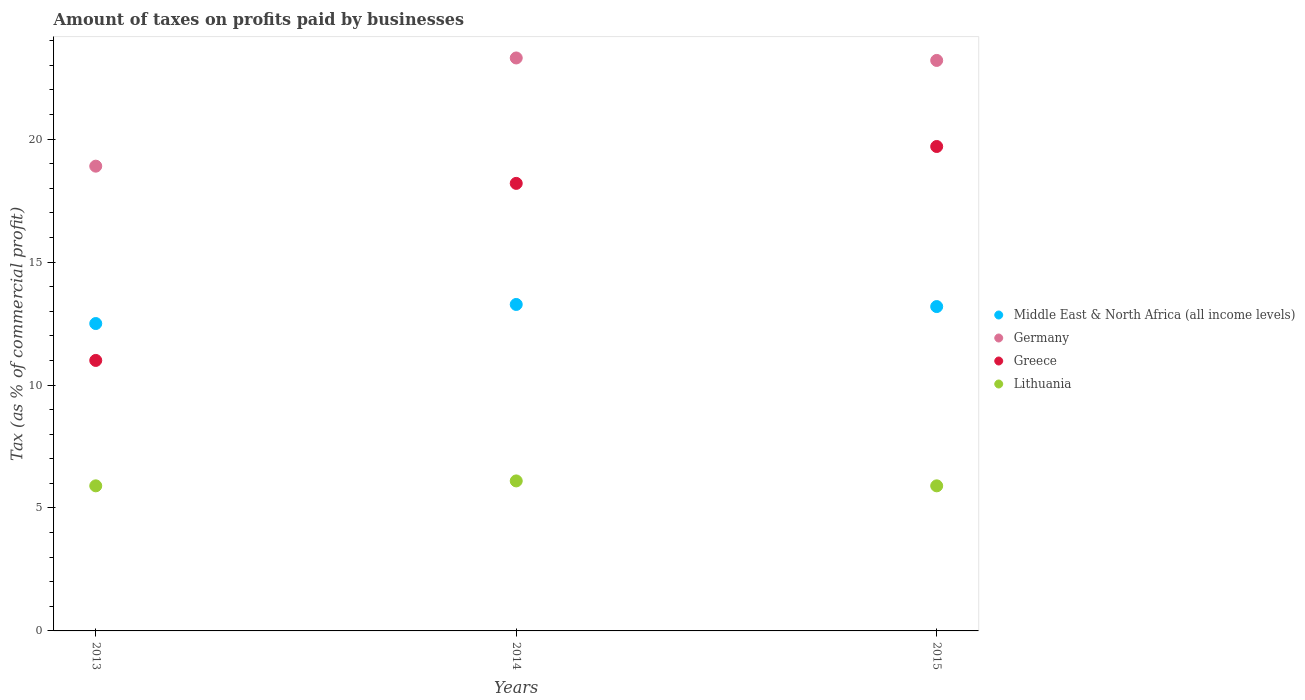How many different coloured dotlines are there?
Provide a short and direct response. 4. What is the percentage of taxes paid by businesses in Lithuania in 2015?
Your response must be concise. 5.9. Across all years, what is the minimum percentage of taxes paid by businesses in Middle East & North Africa (all income levels)?
Provide a short and direct response. 12.5. In which year was the percentage of taxes paid by businesses in Middle East & North Africa (all income levels) maximum?
Offer a very short reply. 2014. What is the total percentage of taxes paid by businesses in Middle East & North Africa (all income levels) in the graph?
Your response must be concise. 38.97. What is the difference between the percentage of taxes paid by businesses in Lithuania in 2014 and that in 2015?
Provide a short and direct response. 0.2. What is the average percentage of taxes paid by businesses in Middle East & North Africa (all income levels) per year?
Give a very brief answer. 12.99. In the year 2013, what is the difference between the percentage of taxes paid by businesses in Lithuania and percentage of taxes paid by businesses in Greece?
Keep it short and to the point. -5.1. In how many years, is the percentage of taxes paid by businesses in Greece greater than 16 %?
Give a very brief answer. 2. What is the ratio of the percentage of taxes paid by businesses in Germany in 2014 to that in 2015?
Offer a very short reply. 1. Is the percentage of taxes paid by businesses in Lithuania in 2014 less than that in 2015?
Offer a terse response. No. What is the difference between the highest and the second highest percentage of taxes paid by businesses in Greece?
Give a very brief answer. 1.5. What is the difference between the highest and the lowest percentage of taxes paid by businesses in Lithuania?
Keep it short and to the point. 0.2. Is the sum of the percentage of taxes paid by businesses in Germany in 2013 and 2015 greater than the maximum percentage of taxes paid by businesses in Greece across all years?
Offer a very short reply. Yes. Is it the case that in every year, the sum of the percentage of taxes paid by businesses in Lithuania and percentage of taxes paid by businesses in Germany  is greater than the percentage of taxes paid by businesses in Middle East & North Africa (all income levels)?
Make the answer very short. Yes. Does the percentage of taxes paid by businesses in Germany monotonically increase over the years?
Ensure brevity in your answer.  No. Is the percentage of taxes paid by businesses in Germany strictly greater than the percentage of taxes paid by businesses in Lithuania over the years?
Your answer should be very brief. Yes. How many dotlines are there?
Provide a short and direct response. 4. How many years are there in the graph?
Provide a short and direct response. 3. What is the difference between two consecutive major ticks on the Y-axis?
Keep it short and to the point. 5. Does the graph contain any zero values?
Provide a succinct answer. No. How are the legend labels stacked?
Offer a terse response. Vertical. What is the title of the graph?
Provide a succinct answer. Amount of taxes on profits paid by businesses. Does "Iceland" appear as one of the legend labels in the graph?
Make the answer very short. No. What is the label or title of the Y-axis?
Give a very brief answer. Tax (as % of commercial profit). What is the Tax (as % of commercial profit) in Middle East & North Africa (all income levels) in 2013?
Your response must be concise. 12.5. What is the Tax (as % of commercial profit) of Lithuania in 2013?
Make the answer very short. 5.9. What is the Tax (as % of commercial profit) in Middle East & North Africa (all income levels) in 2014?
Your answer should be compact. 13.28. What is the Tax (as % of commercial profit) in Germany in 2014?
Your answer should be compact. 23.3. What is the Tax (as % of commercial profit) of Lithuania in 2014?
Your answer should be compact. 6.1. What is the Tax (as % of commercial profit) of Middle East & North Africa (all income levels) in 2015?
Offer a very short reply. 13.19. What is the Tax (as % of commercial profit) of Germany in 2015?
Give a very brief answer. 23.2. What is the Tax (as % of commercial profit) of Greece in 2015?
Ensure brevity in your answer.  19.7. Across all years, what is the maximum Tax (as % of commercial profit) in Middle East & North Africa (all income levels)?
Keep it short and to the point. 13.28. Across all years, what is the maximum Tax (as % of commercial profit) in Germany?
Make the answer very short. 23.3. Across all years, what is the minimum Tax (as % of commercial profit) in Middle East & North Africa (all income levels)?
Ensure brevity in your answer.  12.5. Across all years, what is the minimum Tax (as % of commercial profit) in Germany?
Ensure brevity in your answer.  18.9. What is the total Tax (as % of commercial profit) of Middle East & North Africa (all income levels) in the graph?
Offer a terse response. 38.97. What is the total Tax (as % of commercial profit) in Germany in the graph?
Ensure brevity in your answer.  65.4. What is the total Tax (as % of commercial profit) in Greece in the graph?
Provide a short and direct response. 48.9. What is the difference between the Tax (as % of commercial profit) in Middle East & North Africa (all income levels) in 2013 and that in 2014?
Keep it short and to the point. -0.78. What is the difference between the Tax (as % of commercial profit) of Germany in 2013 and that in 2014?
Offer a terse response. -4.4. What is the difference between the Tax (as % of commercial profit) of Middle East & North Africa (all income levels) in 2013 and that in 2015?
Your response must be concise. -0.69. What is the difference between the Tax (as % of commercial profit) of Greece in 2013 and that in 2015?
Provide a succinct answer. -8.7. What is the difference between the Tax (as % of commercial profit) in Middle East & North Africa (all income levels) in 2014 and that in 2015?
Provide a succinct answer. 0.09. What is the difference between the Tax (as % of commercial profit) in Lithuania in 2014 and that in 2015?
Your answer should be compact. 0.2. What is the difference between the Tax (as % of commercial profit) of Middle East & North Africa (all income levels) in 2013 and the Tax (as % of commercial profit) of Germany in 2014?
Your response must be concise. -10.8. What is the difference between the Tax (as % of commercial profit) of Germany in 2013 and the Tax (as % of commercial profit) of Greece in 2014?
Your answer should be compact. 0.7. What is the difference between the Tax (as % of commercial profit) in Germany in 2013 and the Tax (as % of commercial profit) in Lithuania in 2014?
Your answer should be compact. 12.8. What is the difference between the Tax (as % of commercial profit) of Greece in 2013 and the Tax (as % of commercial profit) of Lithuania in 2014?
Your answer should be compact. 4.9. What is the difference between the Tax (as % of commercial profit) of Middle East & North Africa (all income levels) in 2013 and the Tax (as % of commercial profit) of Greece in 2015?
Make the answer very short. -7.2. What is the difference between the Tax (as % of commercial profit) in Middle East & North Africa (all income levels) in 2014 and the Tax (as % of commercial profit) in Germany in 2015?
Offer a terse response. -9.92. What is the difference between the Tax (as % of commercial profit) in Middle East & North Africa (all income levels) in 2014 and the Tax (as % of commercial profit) in Greece in 2015?
Give a very brief answer. -6.42. What is the difference between the Tax (as % of commercial profit) in Middle East & North Africa (all income levels) in 2014 and the Tax (as % of commercial profit) in Lithuania in 2015?
Your answer should be very brief. 7.38. What is the difference between the Tax (as % of commercial profit) of Germany in 2014 and the Tax (as % of commercial profit) of Greece in 2015?
Provide a short and direct response. 3.6. What is the difference between the Tax (as % of commercial profit) of Germany in 2014 and the Tax (as % of commercial profit) of Lithuania in 2015?
Offer a very short reply. 17.4. What is the average Tax (as % of commercial profit) in Middle East & North Africa (all income levels) per year?
Ensure brevity in your answer.  12.99. What is the average Tax (as % of commercial profit) of Germany per year?
Provide a short and direct response. 21.8. What is the average Tax (as % of commercial profit) of Lithuania per year?
Ensure brevity in your answer.  5.97. In the year 2013, what is the difference between the Tax (as % of commercial profit) in Germany and Tax (as % of commercial profit) in Greece?
Keep it short and to the point. 7.9. In the year 2014, what is the difference between the Tax (as % of commercial profit) in Middle East & North Africa (all income levels) and Tax (as % of commercial profit) in Germany?
Provide a short and direct response. -10.02. In the year 2014, what is the difference between the Tax (as % of commercial profit) in Middle East & North Africa (all income levels) and Tax (as % of commercial profit) in Greece?
Make the answer very short. -4.92. In the year 2014, what is the difference between the Tax (as % of commercial profit) of Middle East & North Africa (all income levels) and Tax (as % of commercial profit) of Lithuania?
Keep it short and to the point. 7.18. In the year 2014, what is the difference between the Tax (as % of commercial profit) in Germany and Tax (as % of commercial profit) in Lithuania?
Your answer should be compact. 17.2. In the year 2015, what is the difference between the Tax (as % of commercial profit) of Middle East & North Africa (all income levels) and Tax (as % of commercial profit) of Germany?
Provide a short and direct response. -10.01. In the year 2015, what is the difference between the Tax (as % of commercial profit) of Middle East & North Africa (all income levels) and Tax (as % of commercial profit) of Greece?
Keep it short and to the point. -6.51. In the year 2015, what is the difference between the Tax (as % of commercial profit) of Middle East & North Africa (all income levels) and Tax (as % of commercial profit) of Lithuania?
Your response must be concise. 7.29. What is the ratio of the Tax (as % of commercial profit) of Middle East & North Africa (all income levels) in 2013 to that in 2014?
Your answer should be compact. 0.94. What is the ratio of the Tax (as % of commercial profit) of Germany in 2013 to that in 2014?
Make the answer very short. 0.81. What is the ratio of the Tax (as % of commercial profit) of Greece in 2013 to that in 2014?
Offer a very short reply. 0.6. What is the ratio of the Tax (as % of commercial profit) of Lithuania in 2013 to that in 2014?
Ensure brevity in your answer.  0.97. What is the ratio of the Tax (as % of commercial profit) in Middle East & North Africa (all income levels) in 2013 to that in 2015?
Offer a very short reply. 0.95. What is the ratio of the Tax (as % of commercial profit) in Germany in 2013 to that in 2015?
Provide a succinct answer. 0.81. What is the ratio of the Tax (as % of commercial profit) of Greece in 2013 to that in 2015?
Make the answer very short. 0.56. What is the ratio of the Tax (as % of commercial profit) in Lithuania in 2013 to that in 2015?
Provide a short and direct response. 1. What is the ratio of the Tax (as % of commercial profit) in Germany in 2014 to that in 2015?
Your response must be concise. 1. What is the ratio of the Tax (as % of commercial profit) in Greece in 2014 to that in 2015?
Provide a succinct answer. 0.92. What is the ratio of the Tax (as % of commercial profit) of Lithuania in 2014 to that in 2015?
Offer a terse response. 1.03. What is the difference between the highest and the second highest Tax (as % of commercial profit) of Middle East & North Africa (all income levels)?
Give a very brief answer. 0.09. What is the difference between the highest and the second highest Tax (as % of commercial profit) of Germany?
Keep it short and to the point. 0.1. What is the difference between the highest and the second highest Tax (as % of commercial profit) of Greece?
Your response must be concise. 1.5. What is the difference between the highest and the lowest Tax (as % of commercial profit) of Middle East & North Africa (all income levels)?
Your answer should be very brief. 0.78. What is the difference between the highest and the lowest Tax (as % of commercial profit) in Germany?
Provide a short and direct response. 4.4. What is the difference between the highest and the lowest Tax (as % of commercial profit) of Lithuania?
Your answer should be compact. 0.2. 